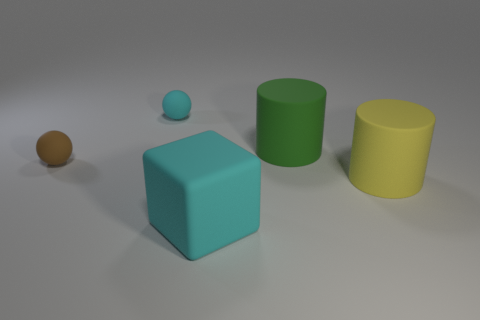Subtract all cyan cylinders. Subtract all brown blocks. How many cylinders are left? 2 Add 5 green balls. How many objects exist? 10 Subtract all balls. How many objects are left? 3 Subtract 1 cyan spheres. How many objects are left? 4 Subtract all yellow rubber cylinders. Subtract all tiny brown rubber blocks. How many objects are left? 4 Add 1 cyan blocks. How many cyan blocks are left? 2 Add 5 purple matte things. How many purple matte things exist? 5 